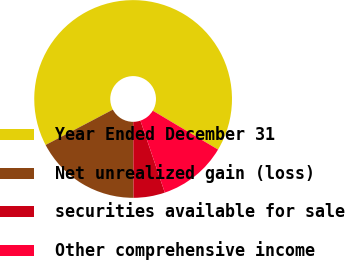<chart> <loc_0><loc_0><loc_500><loc_500><pie_chart><fcel>Year Ended December 31<fcel>Net unrealized gain (loss)<fcel>securities available for sale<fcel>Other comprehensive income<nl><fcel>66.26%<fcel>17.36%<fcel>5.13%<fcel>11.25%<nl></chart> 